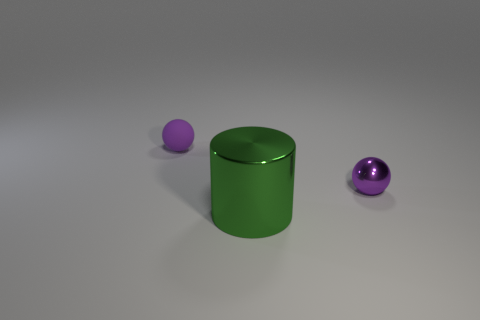Add 1 small matte balls. How many objects exist? 4 Subtract all cylinders. How many objects are left? 2 Add 2 metal objects. How many metal objects are left? 4 Add 3 metallic balls. How many metallic balls exist? 4 Subtract 0 cyan spheres. How many objects are left? 3 Subtract all big cylinders. Subtract all matte spheres. How many objects are left? 1 